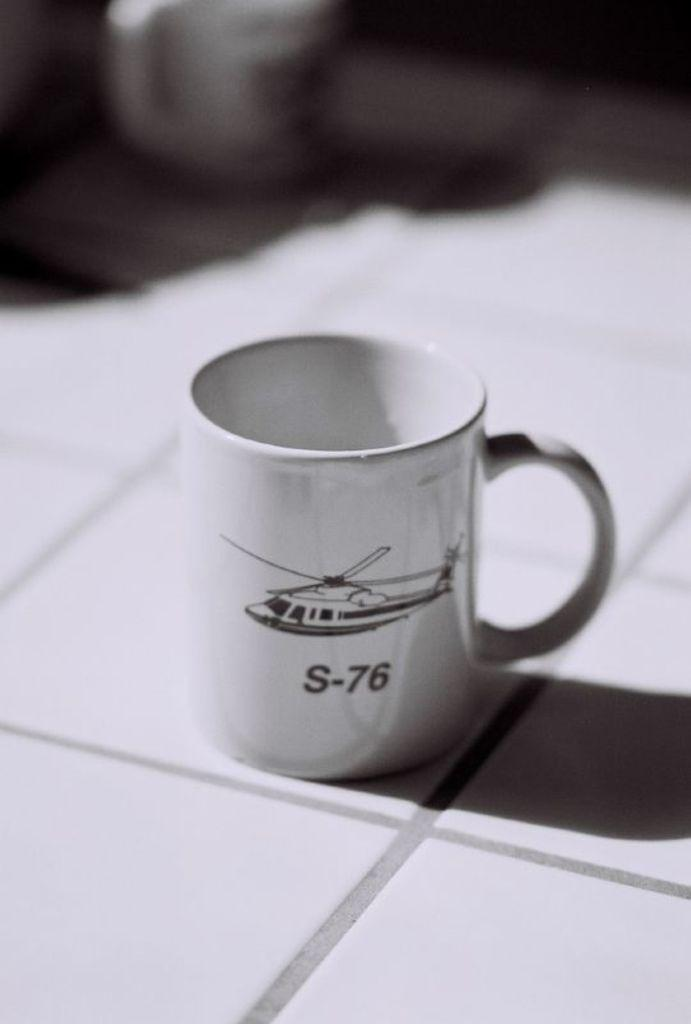<image>
Offer a succinct explanation of the picture presented. A white mug that says S-76 on it sits on white tile. 